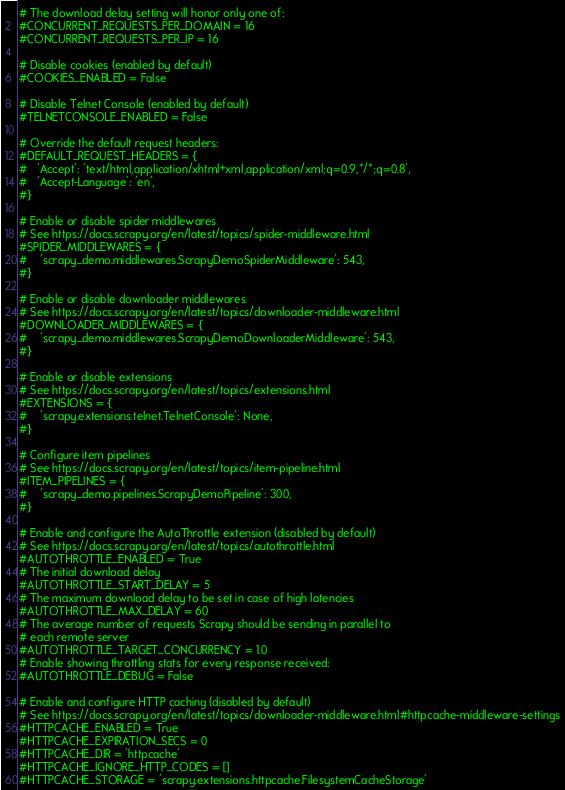Convert code to text. <code><loc_0><loc_0><loc_500><loc_500><_Python_># The download delay setting will honor only one of:
#CONCURRENT_REQUESTS_PER_DOMAIN = 16
#CONCURRENT_REQUESTS_PER_IP = 16

# Disable cookies (enabled by default)
#COOKIES_ENABLED = False

# Disable Telnet Console (enabled by default)
#TELNETCONSOLE_ENABLED = False

# Override the default request headers:
#DEFAULT_REQUEST_HEADERS = {
#   'Accept': 'text/html,application/xhtml+xml,application/xml;q=0.9,*/*;q=0.8',
#   'Accept-Language': 'en',
#}

# Enable or disable spider middlewares
# See https://docs.scrapy.org/en/latest/topics/spider-middleware.html
#SPIDER_MIDDLEWARES = {
#    'scrapy_demo.middlewares.ScrapyDemoSpiderMiddleware': 543,
#}

# Enable or disable downloader middlewares
# See https://docs.scrapy.org/en/latest/topics/downloader-middleware.html
#DOWNLOADER_MIDDLEWARES = {
#    'scrapy_demo.middlewares.ScrapyDemoDownloaderMiddleware': 543,
#}

# Enable or disable extensions
# See https://docs.scrapy.org/en/latest/topics/extensions.html
#EXTENSIONS = {
#    'scrapy.extensions.telnet.TelnetConsole': None,
#}

# Configure item pipelines
# See https://docs.scrapy.org/en/latest/topics/item-pipeline.html
#ITEM_PIPELINES = {
#    'scrapy_demo.pipelines.ScrapyDemoPipeline': 300,
#}

# Enable and configure the AutoThrottle extension (disabled by default)
# See https://docs.scrapy.org/en/latest/topics/autothrottle.html
#AUTOTHROTTLE_ENABLED = True
# The initial download delay
#AUTOTHROTTLE_START_DELAY = 5
# The maximum download delay to be set in case of high latencies
#AUTOTHROTTLE_MAX_DELAY = 60
# The average number of requests Scrapy should be sending in parallel to
# each remote server
#AUTOTHROTTLE_TARGET_CONCURRENCY = 1.0
# Enable showing throttling stats for every response received:
#AUTOTHROTTLE_DEBUG = False

# Enable and configure HTTP caching (disabled by default)
# See https://docs.scrapy.org/en/latest/topics/downloader-middleware.html#httpcache-middleware-settings
#HTTPCACHE_ENABLED = True
#HTTPCACHE_EXPIRATION_SECS = 0
#HTTPCACHE_DIR = 'httpcache'
#HTTPCACHE_IGNORE_HTTP_CODES = []
#HTTPCACHE_STORAGE = 'scrapy.extensions.httpcache.FilesystemCacheStorage'
</code> 